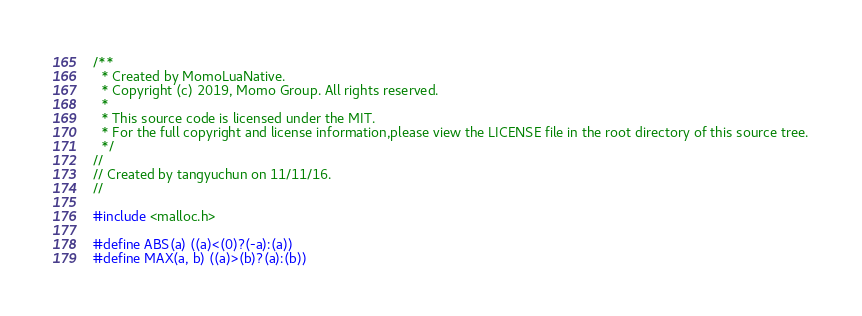<code> <loc_0><loc_0><loc_500><loc_500><_C_>/**
  * Created by MomoLuaNative.
  * Copyright (c) 2019, Momo Group. All rights reserved.
  *
  * This source code is licensed under the MIT.
  * For the full copyright and license information,please view the LICENSE file in the root directory of this source tree.
  */
//
// Created by tangyuchun on 11/11/16.
//

#include <malloc.h>

#define ABS(a) ((a)<(0)?(-a):(a))
#define MAX(a, b) ((a)>(b)?(a):(b))</code> 